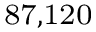<formula> <loc_0><loc_0><loc_500><loc_500>^ { 8 } 7 , 1 2 0</formula> 